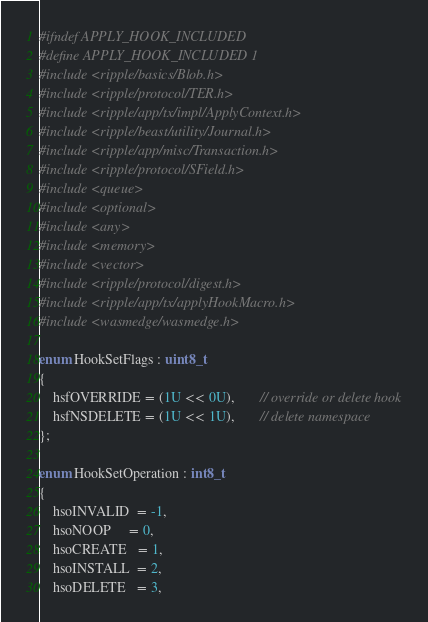Convert code to text. <code><loc_0><loc_0><loc_500><loc_500><_C_>#ifndef APPLY_HOOK_INCLUDED
#define APPLY_HOOK_INCLUDED 1
#include <ripple/basics/Blob.h>
#include <ripple/protocol/TER.h>
#include <ripple/app/tx/impl/ApplyContext.h>
#include <ripple/beast/utility/Journal.h>
#include <ripple/app/misc/Transaction.h>
#include <ripple/protocol/SField.h>
#include <queue>
#include <optional>
#include <any>
#include <memory>
#include <vector>
#include <ripple/protocol/digest.h>
#include <ripple/app/tx/applyHookMacro.h>
#include <wasmedge/wasmedge.h>

enum HookSetFlags : uint8_t
{
    hsfOVERRIDE = (1U << 0U),       // override or delete hook
    hsfNSDELETE = (1U << 1U),       // delete namespace
};

enum HookSetOperation : int8_t
{
    hsoINVALID  = -1,
    hsoNOOP     = 0,
    hsoCREATE   = 1,
    hsoINSTALL  = 2,
    hsoDELETE   = 3,</code> 